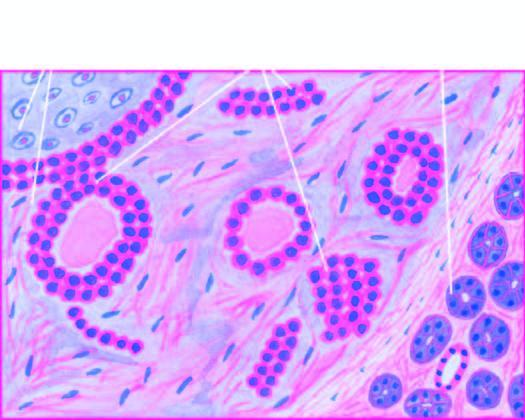s the epithelial element comprised of ducts, acini, tubules, sheets and strands of cuboidal and myoepithelial cells?
Answer the question using a single word or phrase. Yes 